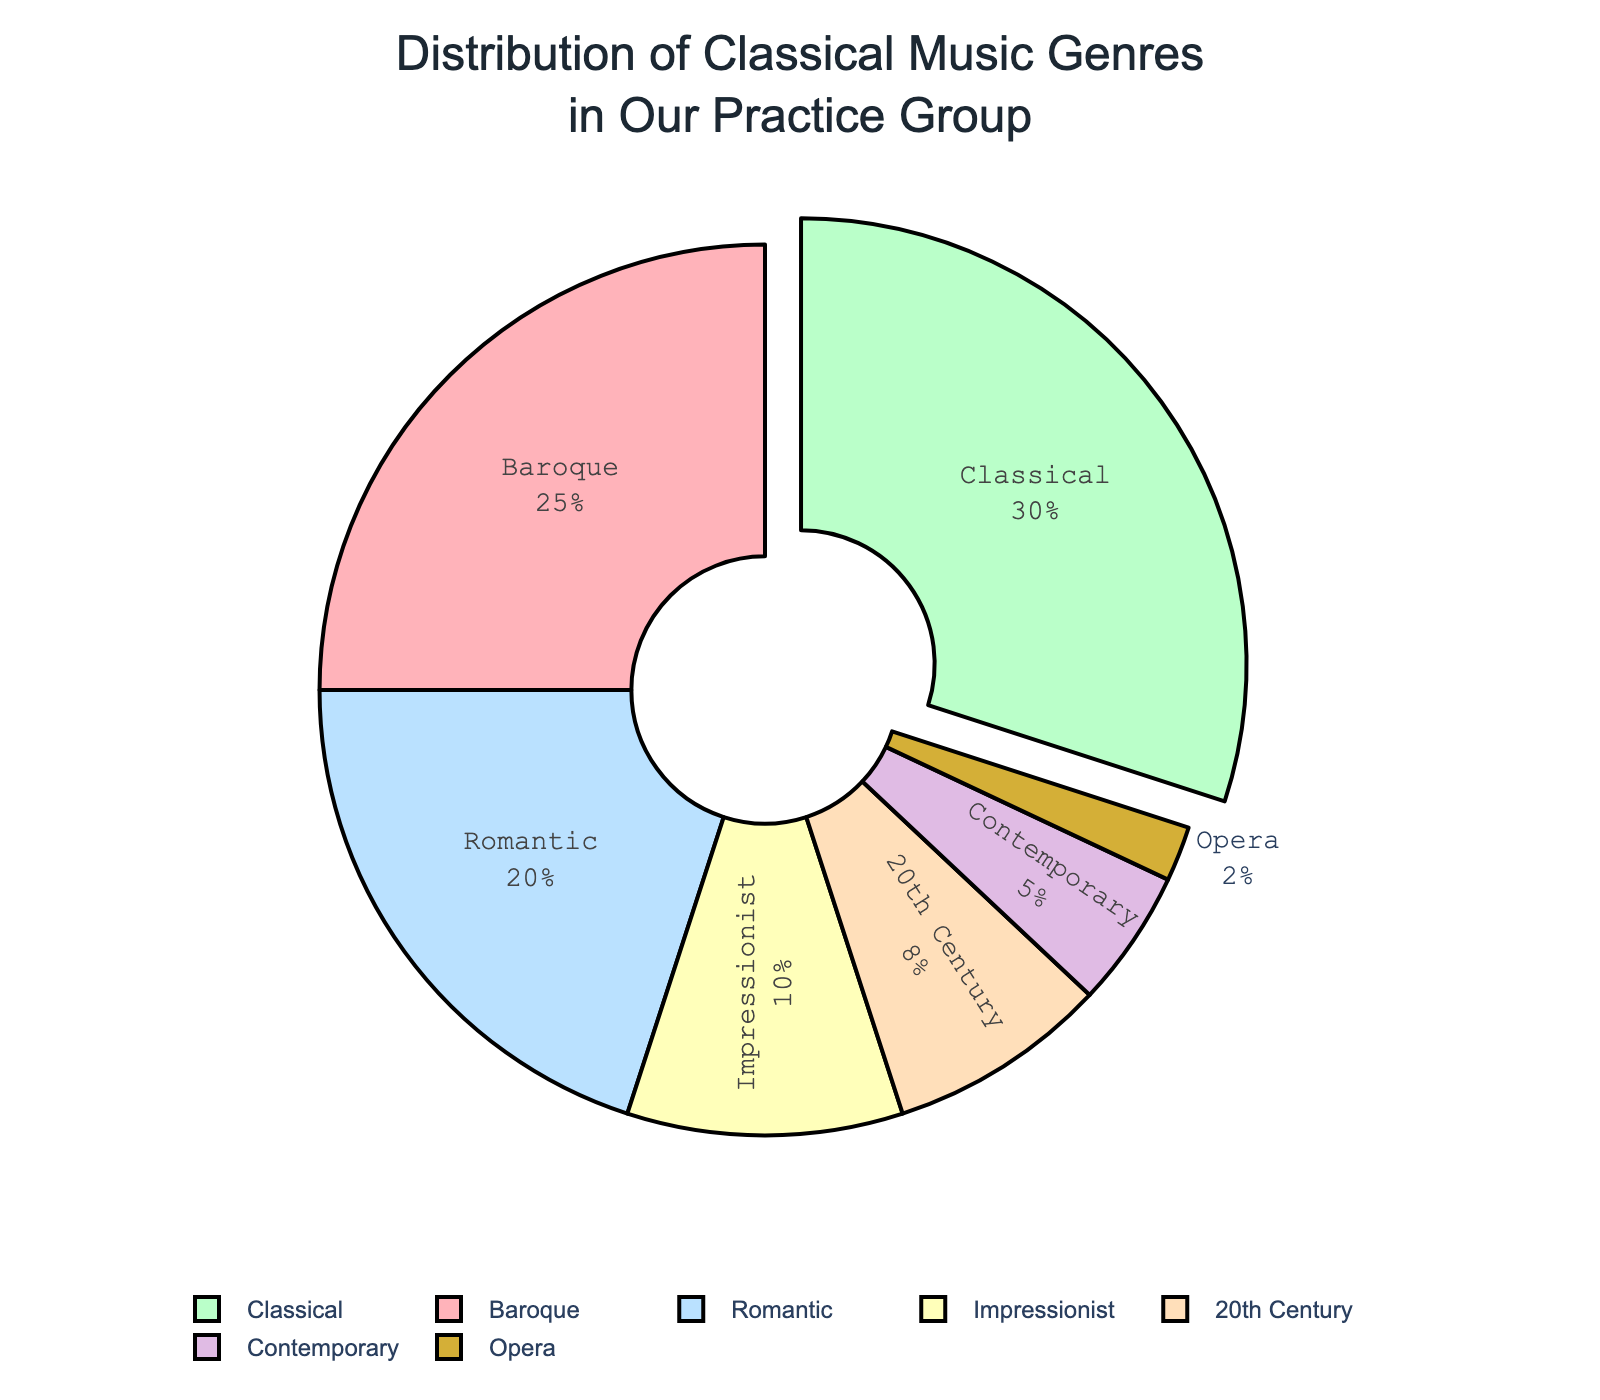What genre is the most practiced in our group? The Classical genre occupies the largest segment of the pie chart.
Answer: Classical Which genre is the least practiced in our group? The Opera genre occupies the smallest segment of the pie chart.
Answer: Opera What is the total percentage of genres practiced that belong to periods before the 20th century? Sum the percentages for Baroque, Classical, Romantic, and Impressionist: 25 + 30 + 20 + 10 = 85%.
Answer: 85% How does the percentage of Romantic music compare to Impressionist music? The percentage of Romantic music (20%) is double that of Impressionist music (10%).
Answer: Double What percentage of the group's practice time is spent on genres other than Baroque, Classical, and Romantic? Subtract the combined percentage of Baroque, Classical, and Romantic (25 + 30 + 20 = 75%) from 100%: 100 - 75 = 25%.
Answer: 25% Which genre segment is represented in a color closest to gold? The Contemporary genre is represented in a color closest to gold (golden hue).
Answer: Contemporary How much more popular is the Baroque genre compared to the 20th Century genre in our group's practice distribution? Subtract the percentage of 20th Century (8%) from Baroque (25%): 25 - 8 = 17%.
Answer: 17% Which genre occupies the smallest percentage and what is this percentage? The Opera genre occupies the smallest percentage and it is 2%.
Answer: Opera, 2% What are the periods of music represented by genres that make up less than 10% of the pie chart? The genres represented by less than 10% of the pie chart are the 20th Century (8%), Contemporary (5%), and Opera (2%).
Answer: 20th Century, Contemporary, Opera 